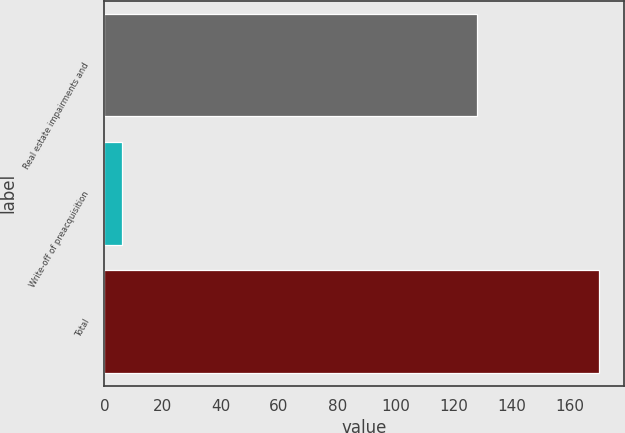Convert chart. <chart><loc_0><loc_0><loc_500><loc_500><bar_chart><fcel>Real estate impairments and<fcel>Write-off of preacquisition<fcel>Total<nl><fcel>128<fcel>6<fcel>170<nl></chart> 